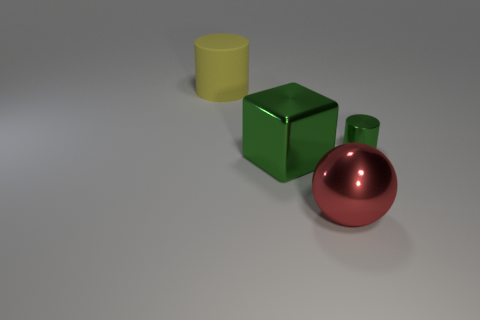Are there any other things that have the same size as the metallic cylinder?
Ensure brevity in your answer.  No. There is a thing behind the tiny object; does it have the same shape as the object that is on the right side of the big metallic ball?
Provide a short and direct response. Yes. How many metal blocks are behind the yellow thing?
Provide a succinct answer. 0. The big shiny object behind the red metallic ball is what color?
Ensure brevity in your answer.  Green. There is another small object that is the same shape as the yellow matte thing; what color is it?
Give a very brief answer. Green. Is there anything else that has the same color as the big metallic cube?
Provide a short and direct response. Yes. Is the number of gray spheres greater than the number of big shiny balls?
Your answer should be very brief. No. Does the red thing have the same material as the yellow cylinder?
Offer a terse response. No. How many big green things have the same material as the red ball?
Offer a terse response. 1. There is a metallic sphere; is it the same size as the cylinder that is to the left of the red object?
Provide a succinct answer. Yes. 